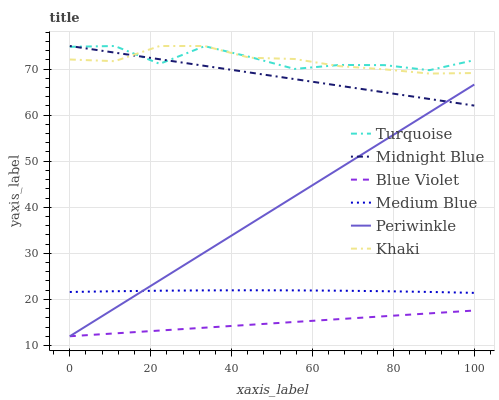Does Blue Violet have the minimum area under the curve?
Answer yes or no. Yes. Does Turquoise have the maximum area under the curve?
Answer yes or no. Yes. Does Khaki have the minimum area under the curve?
Answer yes or no. No. Does Khaki have the maximum area under the curve?
Answer yes or no. No. Is Blue Violet the smoothest?
Answer yes or no. Yes. Is Turquoise the roughest?
Answer yes or no. Yes. Is Khaki the smoothest?
Answer yes or no. No. Is Khaki the roughest?
Answer yes or no. No. Does Khaki have the lowest value?
Answer yes or no. No. Does Medium Blue have the highest value?
Answer yes or no. No. Is Medium Blue less than Turquoise?
Answer yes or no. Yes. Is Midnight Blue greater than Blue Violet?
Answer yes or no. Yes. Does Medium Blue intersect Turquoise?
Answer yes or no. No. 